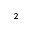Convert formula to latex. <formula><loc_0><loc_0><loc_500><loc_500>^ { 2 }</formula> 